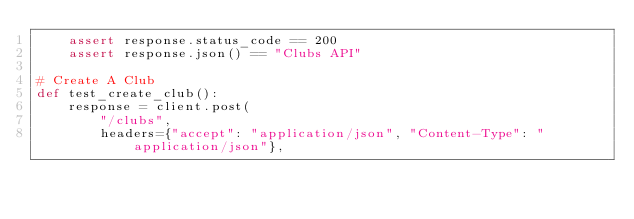Convert code to text. <code><loc_0><loc_0><loc_500><loc_500><_Python_>    assert response.status_code == 200
    assert response.json() == "Clubs API"

# Create A Club
def test_create_club():
    response = client.post(
        "/clubs",
        headers={"accept": "application/json", "Content-Type": "application/json"},</code> 